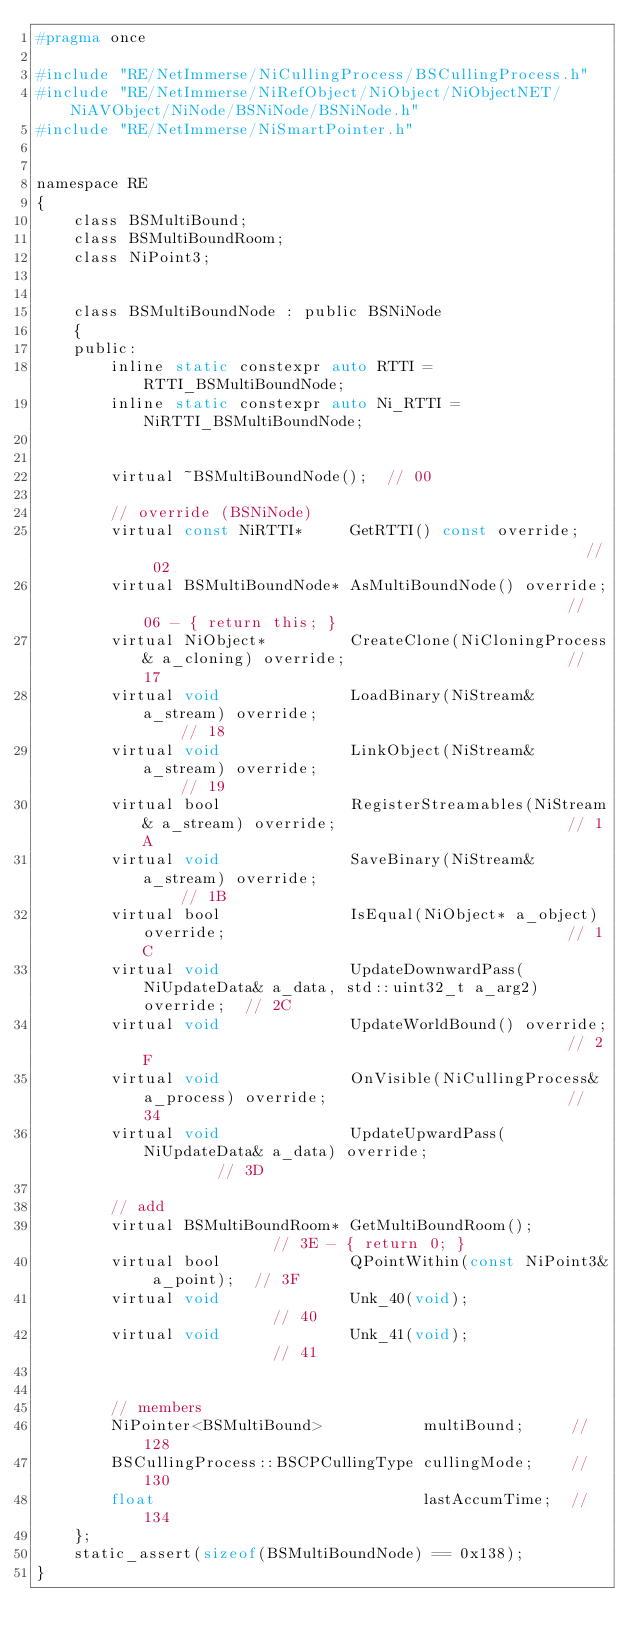<code> <loc_0><loc_0><loc_500><loc_500><_C_>#pragma once

#include "RE/NetImmerse/NiCullingProcess/BSCullingProcess.h"
#include "RE/NetImmerse/NiRefObject/NiObject/NiObjectNET/NiAVObject/NiNode/BSNiNode/BSNiNode.h"
#include "RE/NetImmerse/NiSmartPointer.h"


namespace RE
{
	class BSMultiBound;
	class BSMultiBoundRoom;
	class NiPoint3;


	class BSMultiBoundNode : public BSNiNode
	{
	public:
		inline static constexpr auto RTTI = RTTI_BSMultiBoundNode;
		inline static constexpr auto Ni_RTTI = NiRTTI_BSMultiBoundNode;


		virtual ~BSMultiBoundNode();  // 00

		// override (BSNiNode)
		virtual const NiRTTI*	  GetRTTI() const override;													// 02
		virtual BSMultiBoundNode* AsMultiBoundNode() override;												// 06 - { return this; }
		virtual NiObject*		  CreateClone(NiCloningProcess& a_cloning) override;						// 17
		virtual void			  LoadBinary(NiStream& a_stream) override;									// 18
		virtual void			  LinkObject(NiStream& a_stream) override;									// 19
		virtual bool			  RegisterStreamables(NiStream& a_stream) override;							// 1A
		virtual void			  SaveBinary(NiStream& a_stream) override;									// 1B
		virtual bool			  IsEqual(NiObject* a_object) override;										// 1C
		virtual void			  UpdateDownwardPass(NiUpdateData& a_data, std::uint32_t a_arg2) override;	// 2C
		virtual void			  UpdateWorldBound() override;												// 2F
		virtual void			  OnVisible(NiCullingProcess& a_process) override;							// 34
		virtual void			  UpdateUpwardPass(NiUpdateData& a_data) override;							// 3D

		// add
		virtual BSMultiBoundRoom* GetMultiBoundRoom();					  // 3E - { return 0; }
		virtual bool			  QPointWithin(const NiPoint3& a_point);  // 3F
		virtual void			  Unk_40(void);							  // 40
		virtual void			  Unk_41(void);							  // 41


		// members
		NiPointer<BSMultiBound>			  multiBound;	  // 128
		BSCullingProcess::BSCPCullingType cullingMode;	  // 130
		float							  lastAccumTime;  // 134
	};
	static_assert(sizeof(BSMultiBoundNode) == 0x138);
}
</code> 